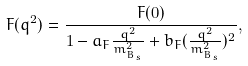Convert formula to latex. <formula><loc_0><loc_0><loc_500><loc_500>F ( q ^ { 2 } ) = \frac { F ( 0 ) } { 1 - a _ { F } \frac { q ^ { 2 } } { m _ { B _ { s } } ^ { 2 } } + b _ { F } ( \frac { q ^ { 2 } } { m _ { B _ { s } } ^ { 2 } } ) ^ { 2 } } ,</formula> 